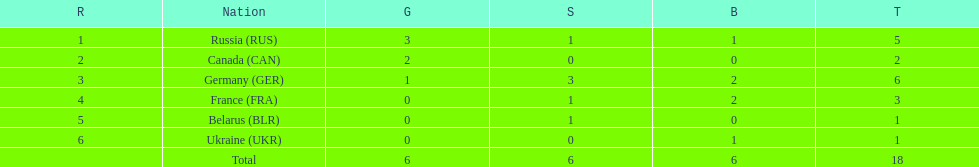Which country won the same amount of silver medals as the french and the russians? Belarus. Help me parse the entirety of this table. {'header': ['R', 'Nation', 'G', 'S', 'B', 'T'], 'rows': [['1', 'Russia\xa0(RUS)', '3', '1', '1', '5'], ['2', 'Canada\xa0(CAN)', '2', '0', '0', '2'], ['3', 'Germany\xa0(GER)', '1', '3', '2', '6'], ['4', 'France\xa0(FRA)', '0', '1', '2', '3'], ['5', 'Belarus\xa0(BLR)', '0', '1', '0', '1'], ['6', 'Ukraine\xa0(UKR)', '0', '0', '1', '1'], ['', 'Total', '6', '6', '6', '18']]} 